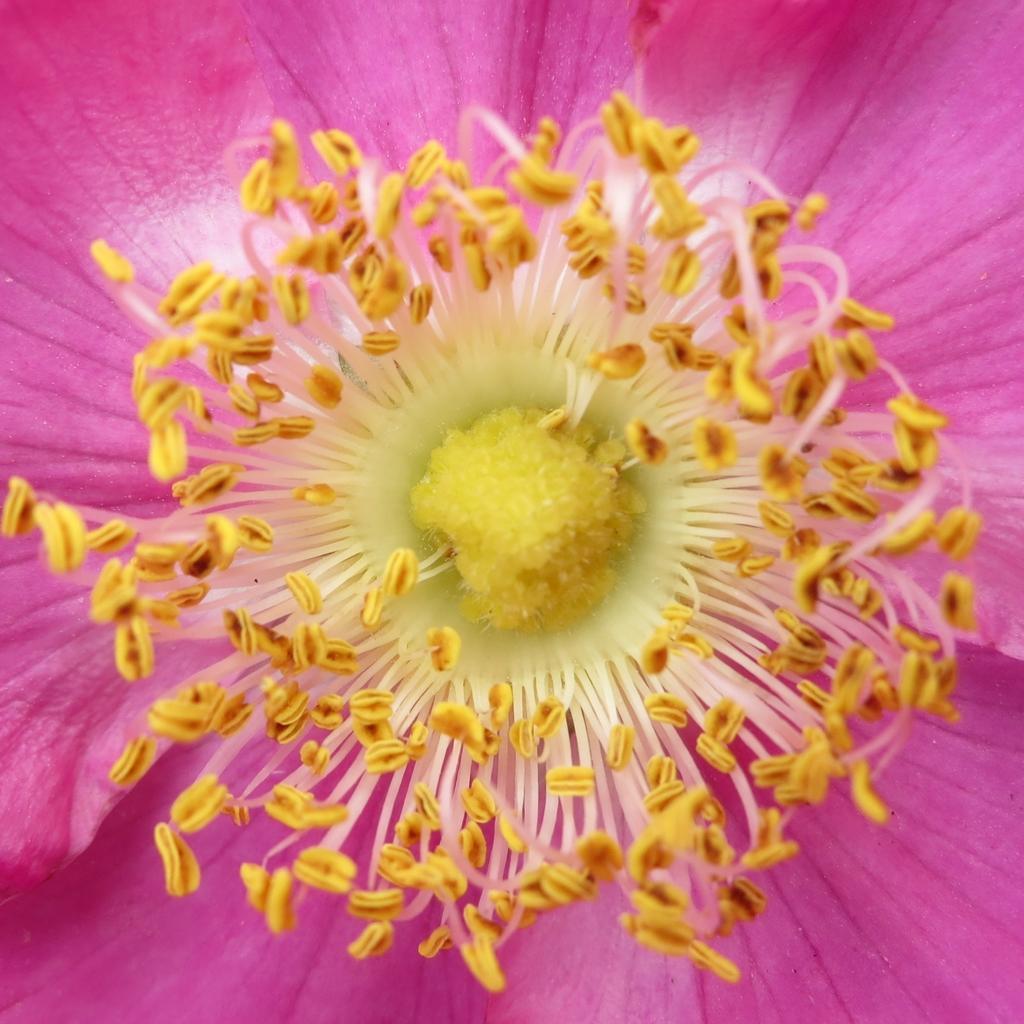Please provide a concise description of this image. In this image we can see a flower. 